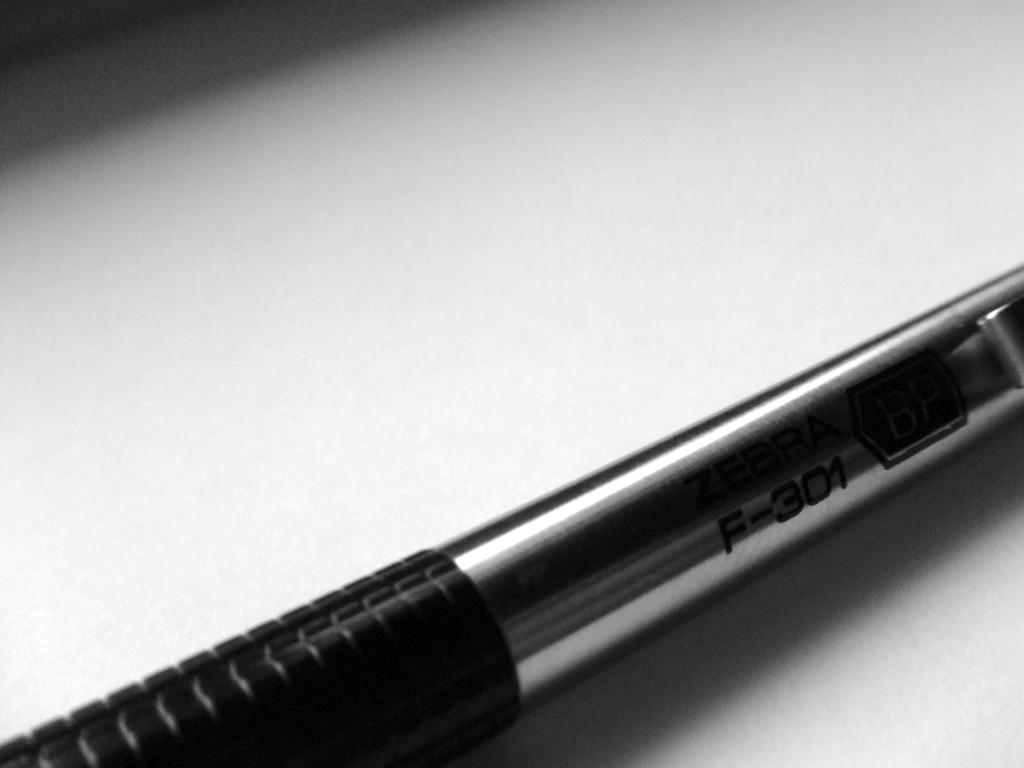What object can be seen in the image? There is a pen in the image. What colors are present on the pen? The pen has black and gray colors. On what surface is the pen placed? The pen is on a white surface. What type of bird can be seen in the image? There is no bird present in the image; it only features a pen on a white surface. 